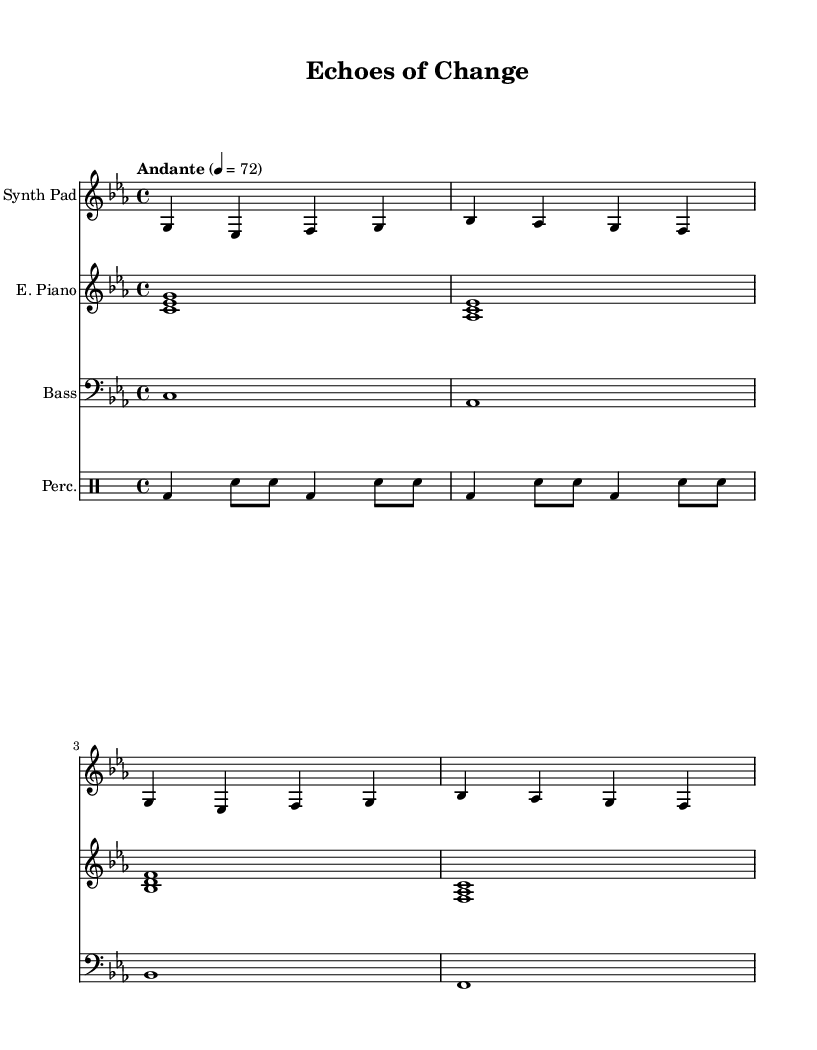What is the key signature of this music? The key signature is C minor, which contains three flats. This can be identified in the key signature section at the beginning of the sheet music.
Answer: C minor What is the time signature of this music? The time signature is 4/4, which indicates four beats per measure and is shown at the start of the sheet music.
Answer: 4/4 What is the tempo marking of this piece? The tempo marking is "Andante," which is typically understood to mean a moderately slow pace. This is indicated in the tempo section of the sheet music.
Answer: Andante How many different instruments are featured in this score? There are four different instruments in this score: Synth Pad, Electric Piano, Bass, and Percussion. Each is indicated by a separate staff in the score.
Answer: Four What type of texture does the music primarily exhibit? The texture is primarily homophonic, containing melodies supported by harmonies, as observed in the layered structure with distinct instrumental lines working together.
Answer: Homophonic Which instrument plays the bass line? The bass line is played by the staff designated as "Bass," which uses the bass clef. The notes written are low pitch, characteristic of a bass instrument.
Answer: Bass What role does percussion play in this piece? The percussion adds rhythmic support and texture, enhancing the overall sound with rhythmic patterns. This is indicated by the drummode section showing the drumbeat patterns being utilized.
Answer: Rhythmic support 